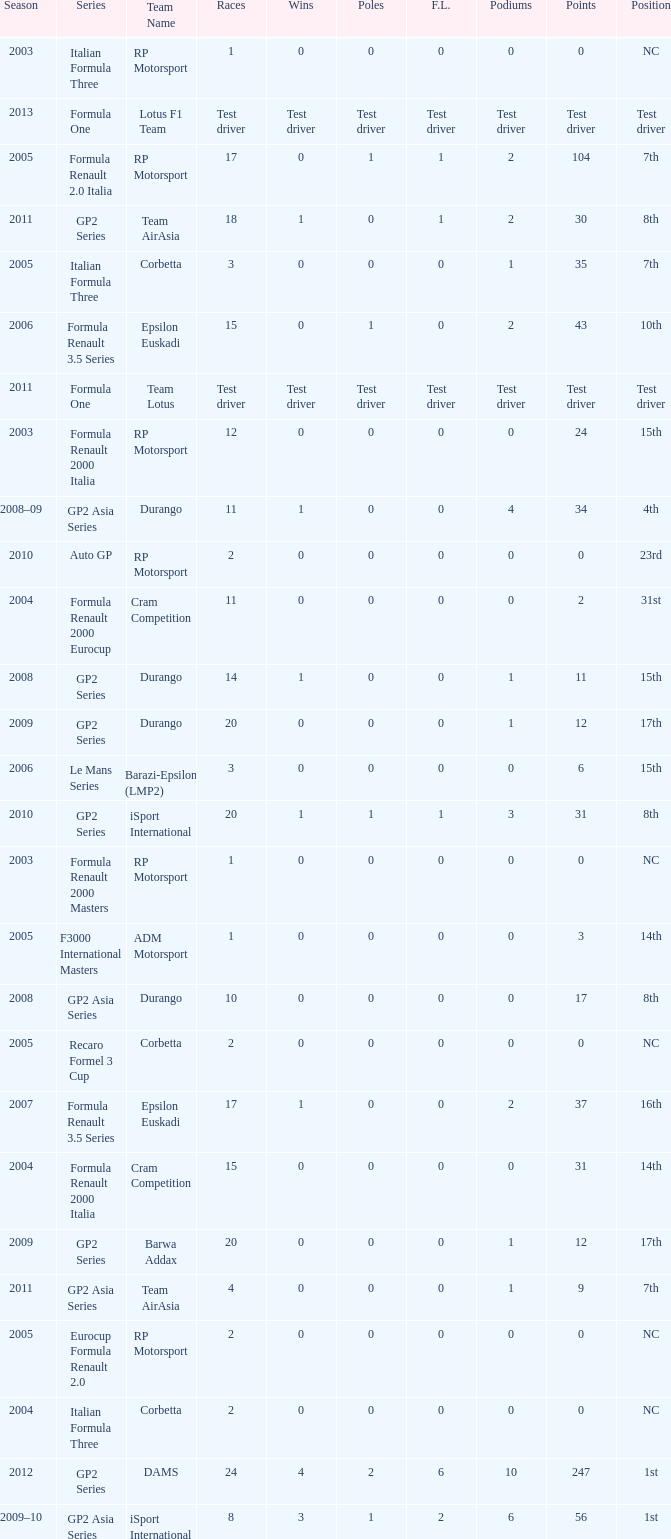What races have gp2 series, 0 F.L. and a 17th position? 20, 20. 